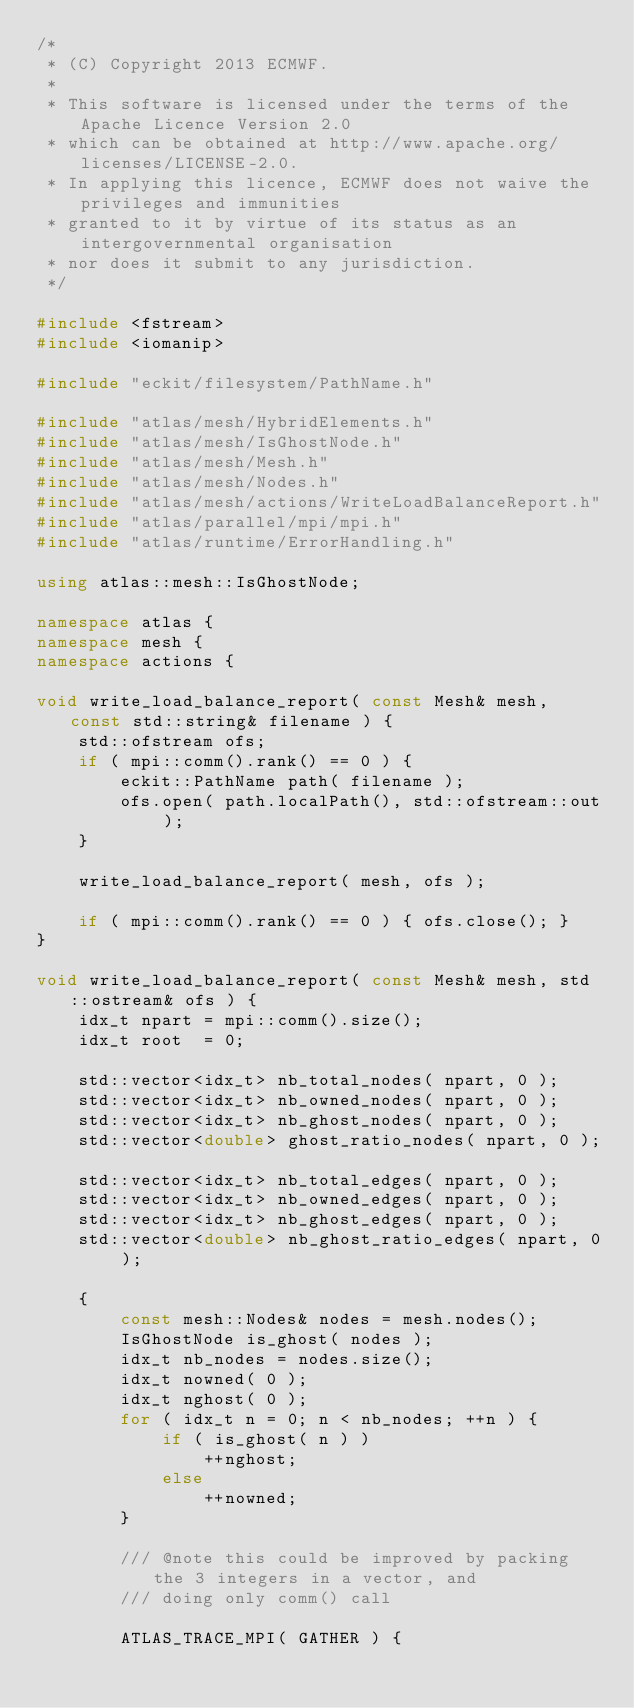Convert code to text. <code><loc_0><loc_0><loc_500><loc_500><_C++_>/*
 * (C) Copyright 2013 ECMWF.
 *
 * This software is licensed under the terms of the Apache Licence Version 2.0
 * which can be obtained at http://www.apache.org/licenses/LICENSE-2.0.
 * In applying this licence, ECMWF does not waive the privileges and immunities
 * granted to it by virtue of its status as an intergovernmental organisation
 * nor does it submit to any jurisdiction.
 */

#include <fstream>
#include <iomanip>

#include "eckit/filesystem/PathName.h"

#include "atlas/mesh/HybridElements.h"
#include "atlas/mesh/IsGhostNode.h"
#include "atlas/mesh/Mesh.h"
#include "atlas/mesh/Nodes.h"
#include "atlas/mesh/actions/WriteLoadBalanceReport.h"
#include "atlas/parallel/mpi/mpi.h"
#include "atlas/runtime/ErrorHandling.h"

using atlas::mesh::IsGhostNode;

namespace atlas {
namespace mesh {
namespace actions {

void write_load_balance_report( const Mesh& mesh, const std::string& filename ) {
    std::ofstream ofs;
    if ( mpi::comm().rank() == 0 ) {
        eckit::PathName path( filename );
        ofs.open( path.localPath(), std::ofstream::out );
    }

    write_load_balance_report( mesh, ofs );

    if ( mpi::comm().rank() == 0 ) { ofs.close(); }
}

void write_load_balance_report( const Mesh& mesh, std::ostream& ofs ) {
    idx_t npart = mpi::comm().size();
    idx_t root  = 0;

    std::vector<idx_t> nb_total_nodes( npart, 0 );
    std::vector<idx_t> nb_owned_nodes( npart, 0 );
    std::vector<idx_t> nb_ghost_nodes( npart, 0 );
    std::vector<double> ghost_ratio_nodes( npart, 0 );

    std::vector<idx_t> nb_total_edges( npart, 0 );
    std::vector<idx_t> nb_owned_edges( npart, 0 );
    std::vector<idx_t> nb_ghost_edges( npart, 0 );
    std::vector<double> nb_ghost_ratio_edges( npart, 0 );

    {
        const mesh::Nodes& nodes = mesh.nodes();
        IsGhostNode is_ghost( nodes );
        idx_t nb_nodes = nodes.size();
        idx_t nowned( 0 );
        idx_t nghost( 0 );
        for ( idx_t n = 0; n < nb_nodes; ++n ) {
            if ( is_ghost( n ) )
                ++nghost;
            else
                ++nowned;
        }

        /// @note this could be improved by packing the 3 integers in a vector, and
        /// doing only comm() call

        ATLAS_TRACE_MPI( GATHER ) {</code> 